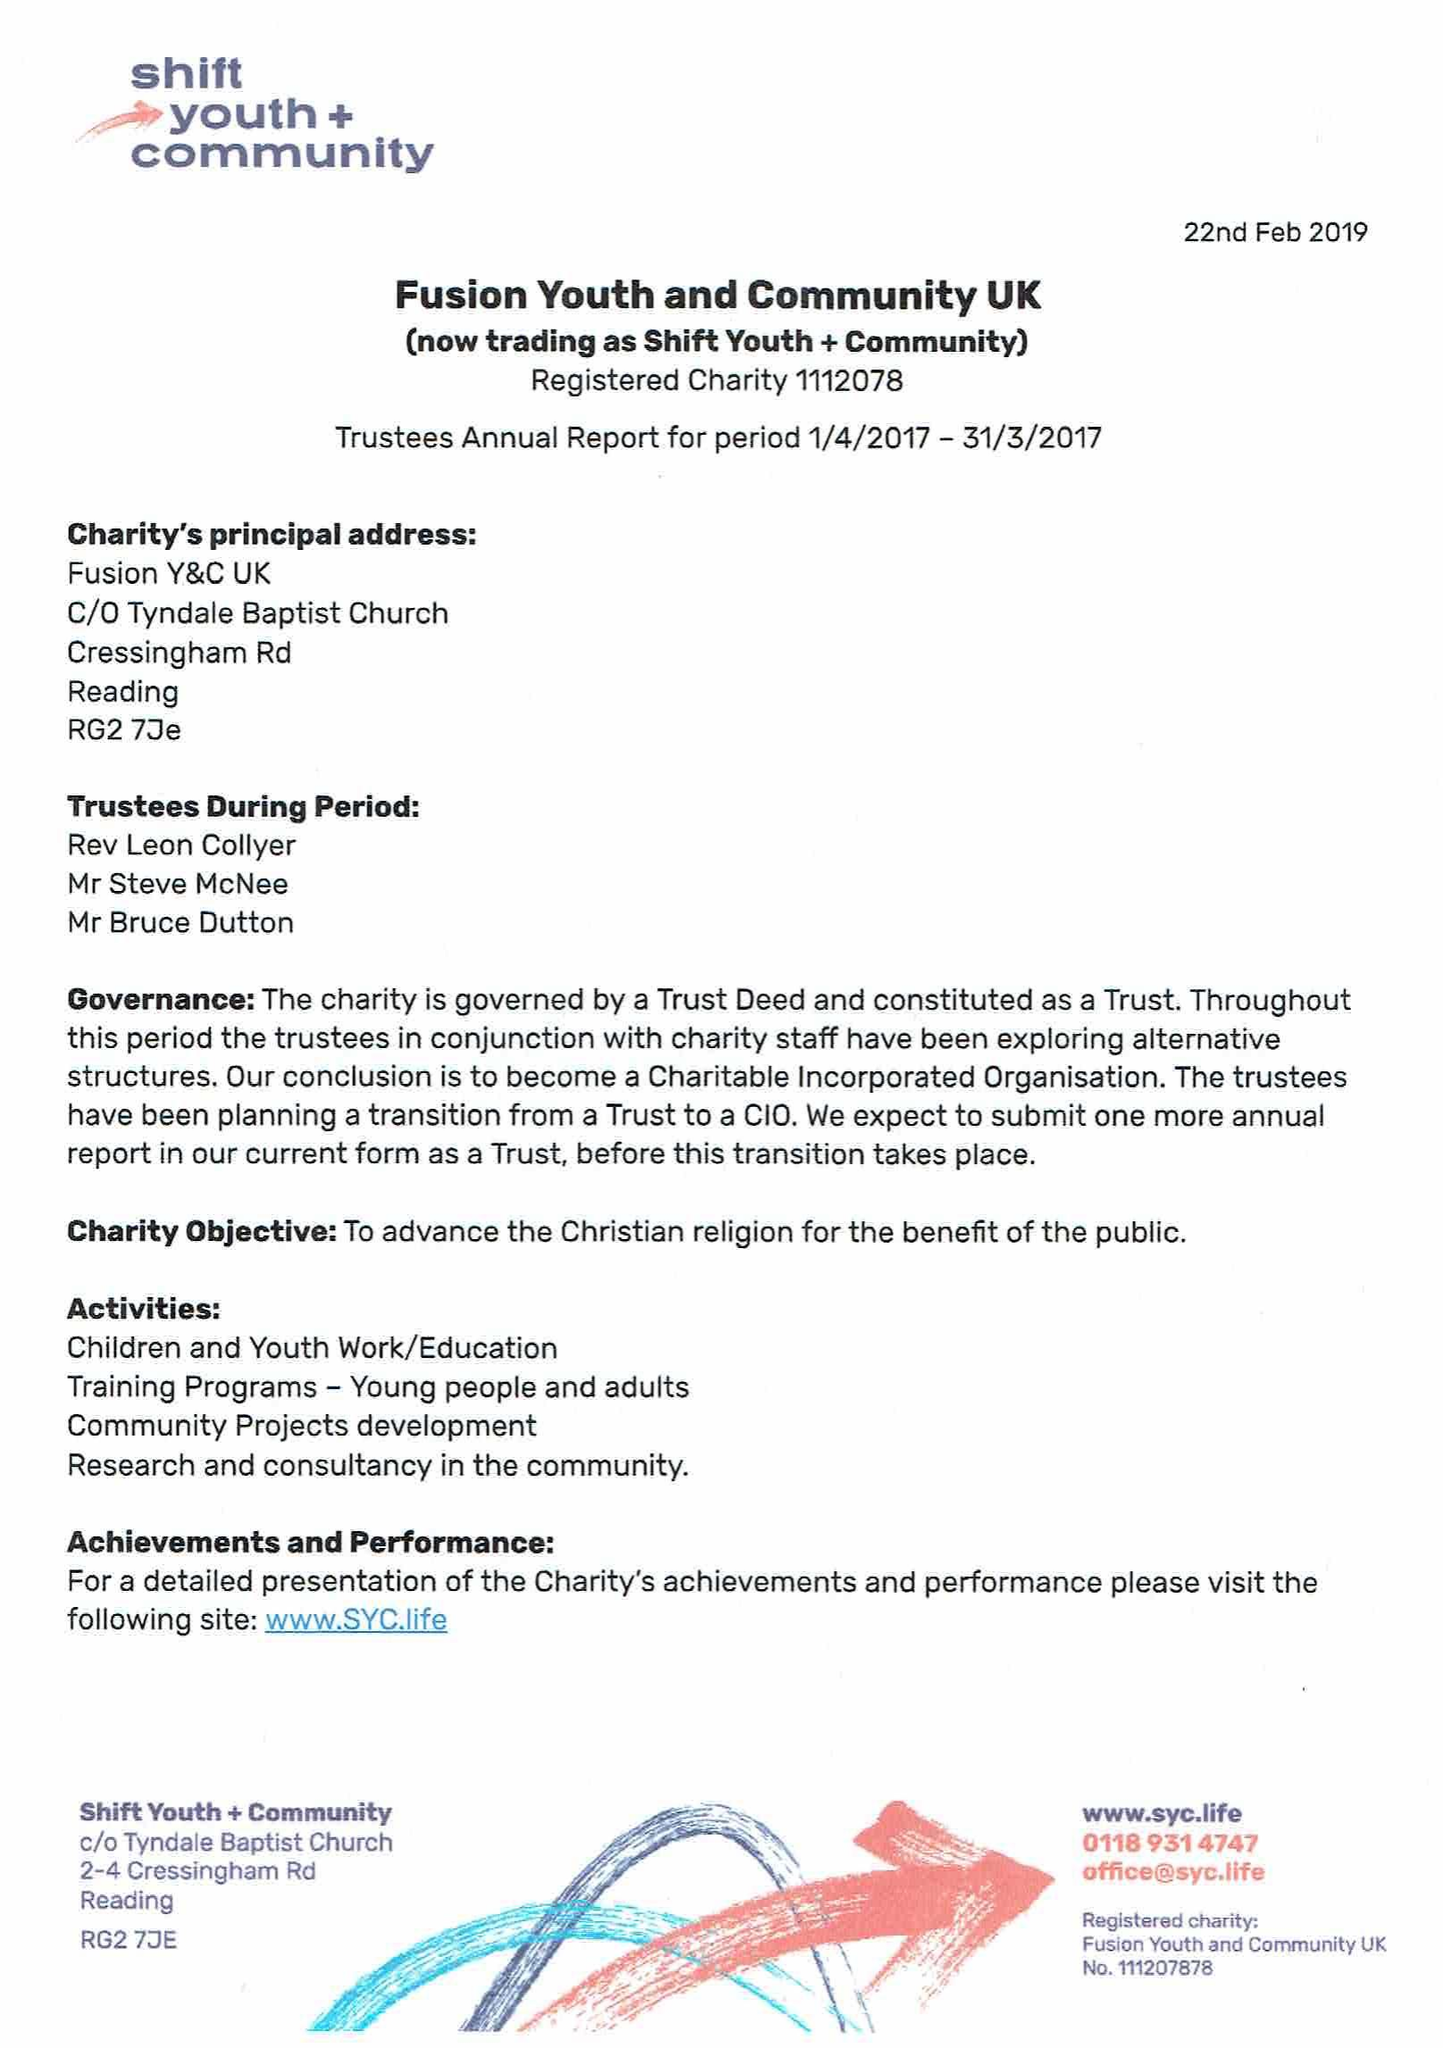What is the value for the address__post_town?
Answer the question using a single word or phrase. READING 